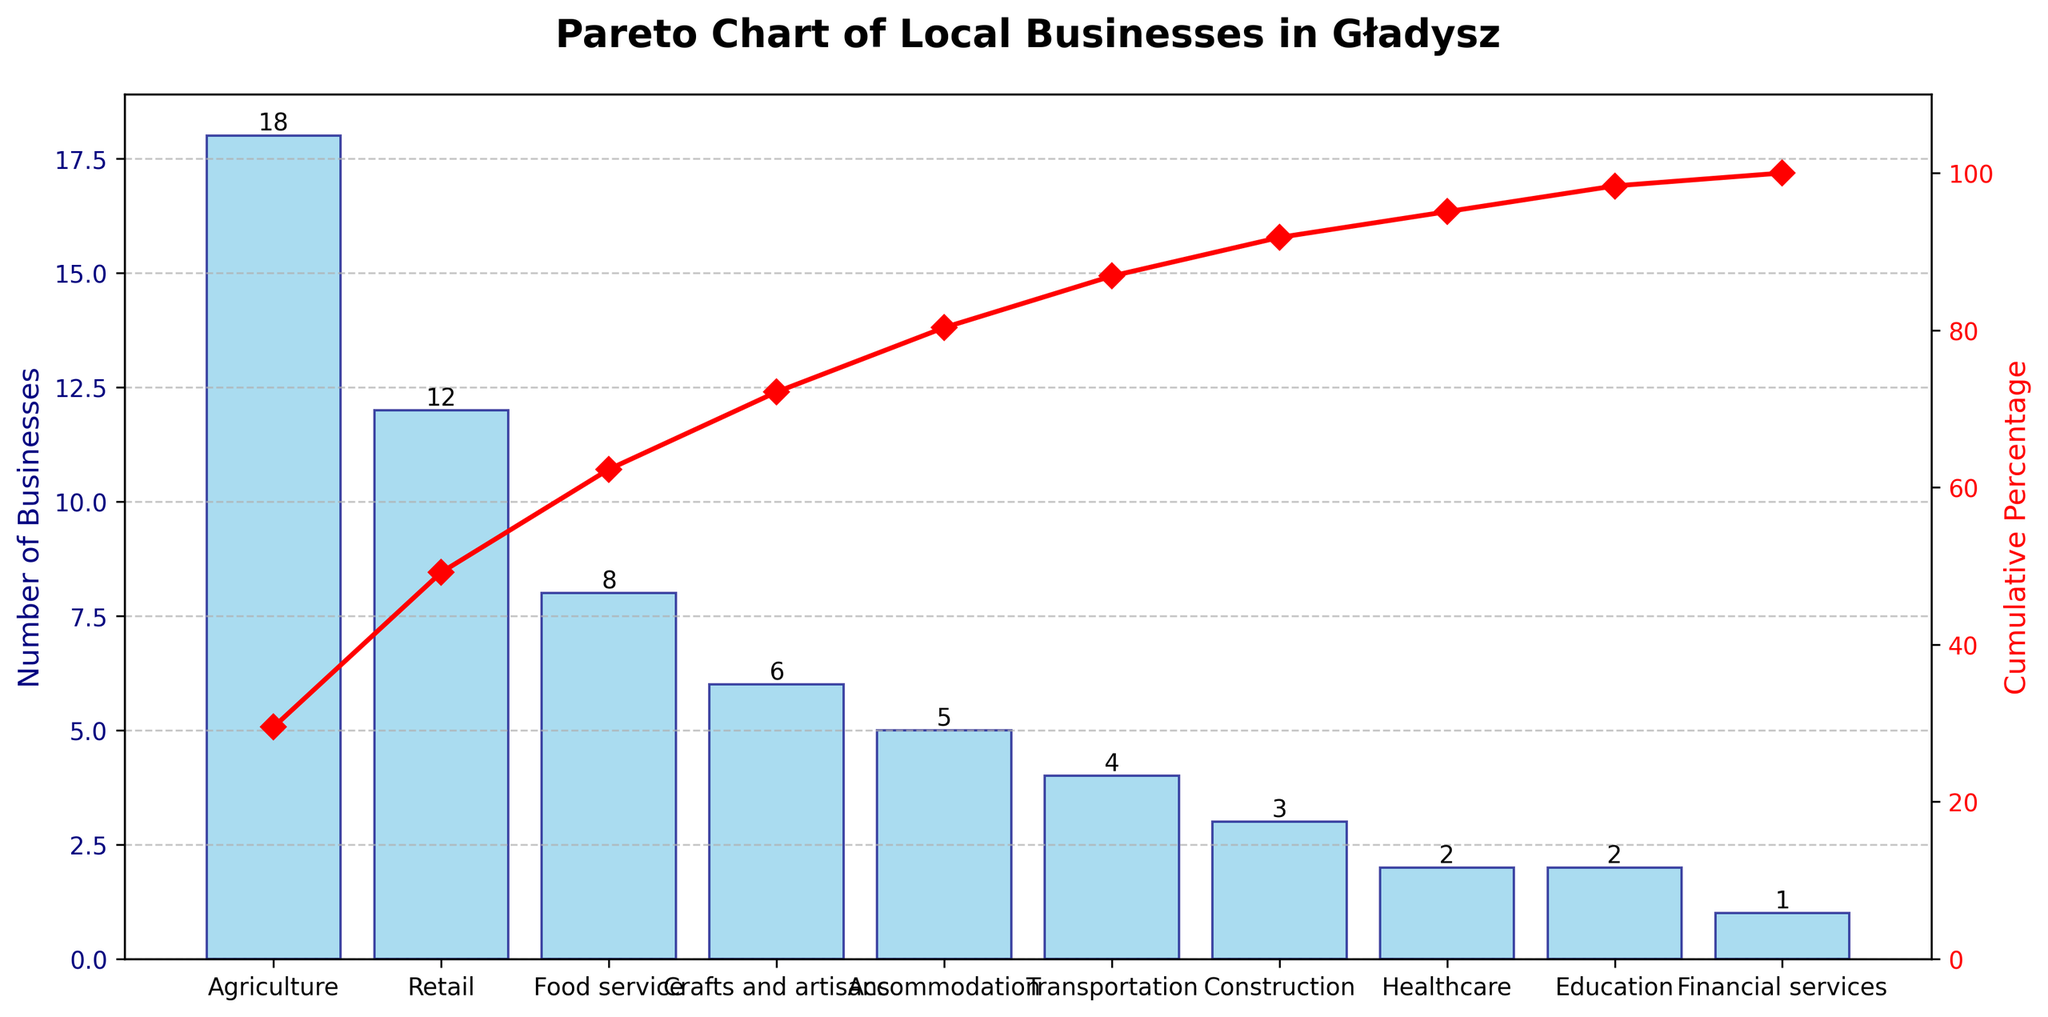What is the title of the chart? The title is located at the top of the chart, and it provides the primary subject of the figure. The information directly indicates the nature of the data being presented.
Answer: Pareto Chart of Local Businesses in Gładysz Which industry has the highest number of businesses? The industry with the highest number of businesses will have the tallest bar in the chart. You can identify it by looking at the bars from left to right and selecting the one that is the tallest.
Answer: Agriculture How many total local businesses are there in Gładysz? To find the total number of businesses, you need to sum the values of each bar. This involves adding the numbers of businesses for all industries listed in the chart.
Answer: 61 What is the cumulative percentage of businesses achieved with the top three industries? To determine this, first identify the top three industries by sorting them in order based on the height of the bars. Then look at the cumulative percentage curve to find the value at the third industry.
Answer: 62.3% What is the difference in the number of businesses between the Retail and Construction industries? Identify the height of the bars for the Retail and Construction industries, then subtract the number of businesses in Construction from those in Retail.
Answer: 9 Which industry marks the point where the cumulative percentage first exceeds 80%? Follow the cumulative percentage line until it passes the 80% mark, then look down to the corresponding industry label.
Answer: Transportation Which two industries have the same number of businesses, and what is that number? Review the heights of all the bars and identify those which match in value. Here, you will notice two bars with the same height count of 2.
Answer: Healthcare and Education, 2 What is the combined percentage of businesses for Food service, Accommodation, and Transportation industries? Add the number of businesses in the Food service, Accommodation, and Transportation industries, then divide that sum by the total number of businesses and multiply by 100 to get the percentage.
Answer: 27.9% How does the number of businesses in the Crafts and artisans category compare to the number of financial services businesses? Find the heights of the bars corresponding to Crafts and artisans and Financial services, then compare them directly to see how they differ.
Answer: Crafts and artisans have 5 more businesses than Financial services If you were to add one more business in Healthcare, what would be its new cumulative percentage? First, note the number of businesses currently in Healthcare and then calculate the new cumulative percentage by adding this new business. Update the total number of businesses and recompute the cumulative percentage.
Answer: 96.7% 